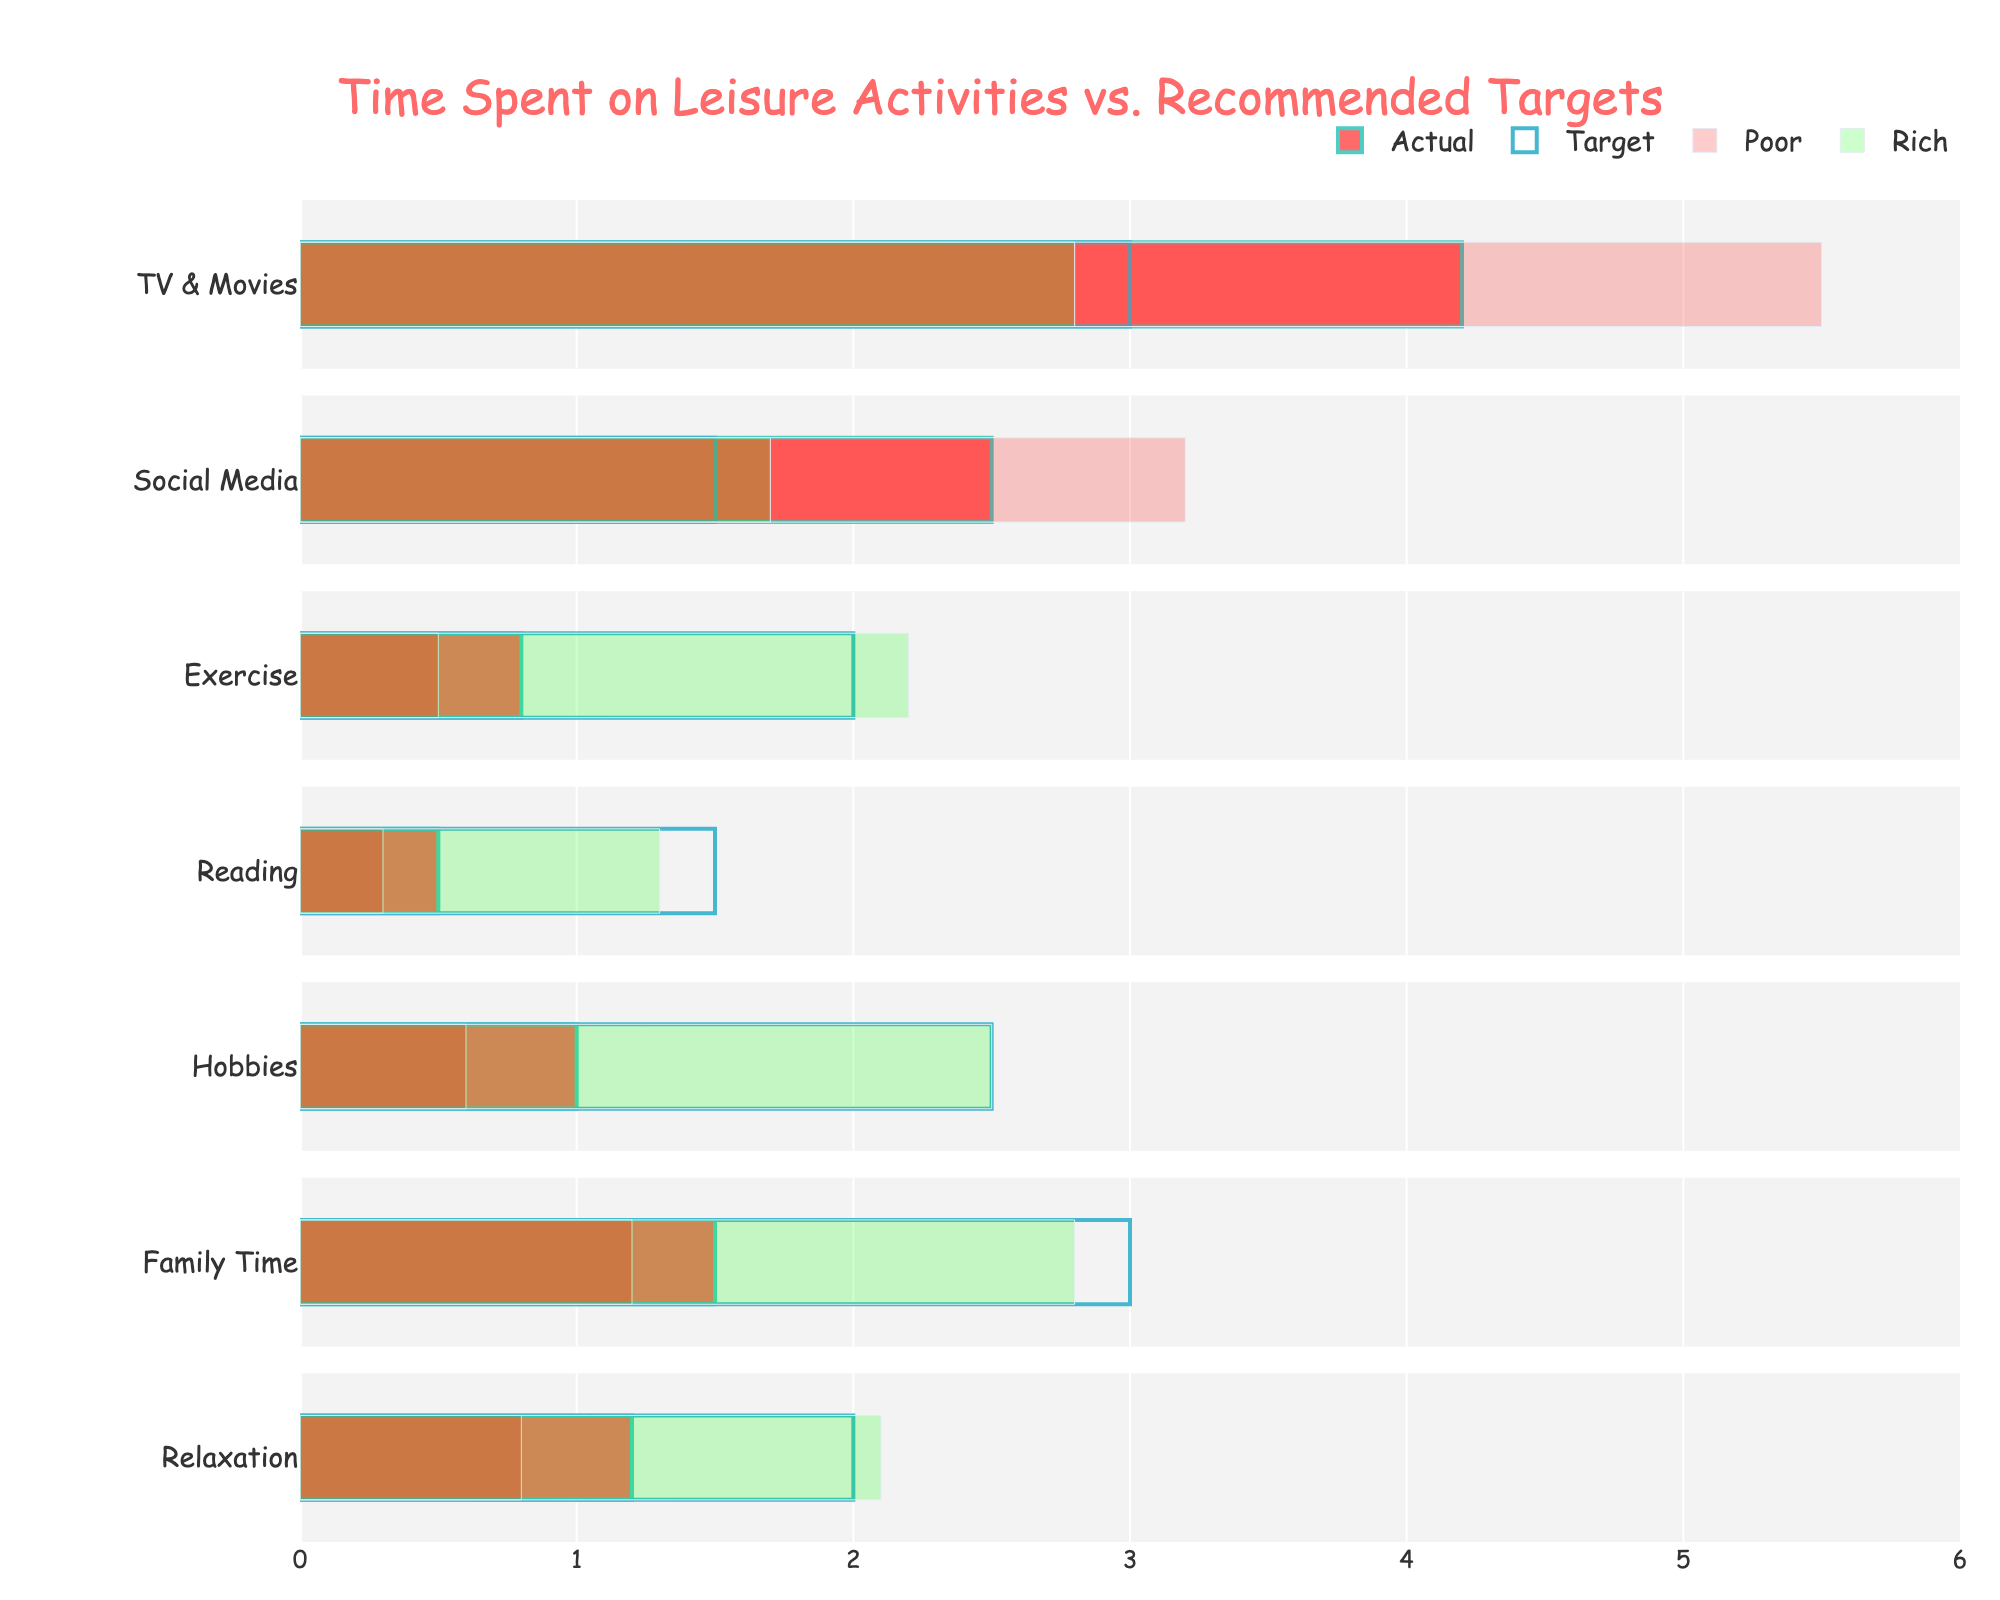What's the title of the figure? The title of the figure is located at the top and reads "Time Spent on Leisure Activities vs. Recommended Targets."
Answer: Time Spent on Leisure Activities vs. Recommended Targets Which category has the highest actual hours spent? The category with the highest actual hours spent is indicated by the longest red bar among the actual hours. "TV & Movies" has the longest red bar with 4.2 hours.
Answer: TV & Movies How many categories have the rich meeting or exceeding the recommended target for hobby time? We need to check the "Hobbies" category and see if the green bar representing the rich meets or exceeds the blue target bar. For hobbies, the rich (2.5 hours) meet the target (2.5 hours).
Answer: 1 What is the difference in hours spent on exercise between the poor and the recommended target? To find the difference, subtract the poor's hours (0.5) from the recommended target hours (2.0). 2.0 - 0.5 = 1.5 hours.
Answer: 1.5 hours Which category shows the smallest gap between the actual hours and the recommended target? Compare the red (actual) and blue (target) bars across all categories to find the smallest difference. "Reading" shows the smallest gap, with actual hours being 0.5 and the target being 1.5, which is a difference of 1.0 hours.
Answer: Reading In which category do the rich spend the most time relative to the poor? Check the green bar (rich) and red bar (poor) for each category and find where the difference is largest. The greatest difference is in "Exercise," where the rich spend 2.2 hours and the poor spend 0.5 hours, a difference of 1.7 hours.
Answer: Exercise Which income bracket has the closest actual hours to the target for family time? Compare the actual hours for family time for all income brackets to the target (3.0 hours). The rich spend 2.8 hours, which is closest to the target of 3.0 hours.
Answer: Rich What is the combined actual time spent on social media, exercise, and reading by the working class? Sum the actual hours for social media (2.8), exercise (0.7), and reading (0.4) for the working class. 2.8 + 0.7 + 0.4 = 3.9 hours.
Answer: 3.9 hours Which category has the largest spread between the different income levels for actual hours? Look for the category where the difference between the highest and lowest actual hours among income brackets is the greatest. "Social Media" has the largest spread with the poor spending 3.2 hours and the rich spending 1.7 hours, a difference of 1.5 hours.
Answer: Social Media Do any income brackets meet the recommended target for TV & Movies? Check if any of the income brackets meet the target of 3.0 hours. None of the income brackets meet the target; the closest is the rich with 2.8 hours.
Answer: No 